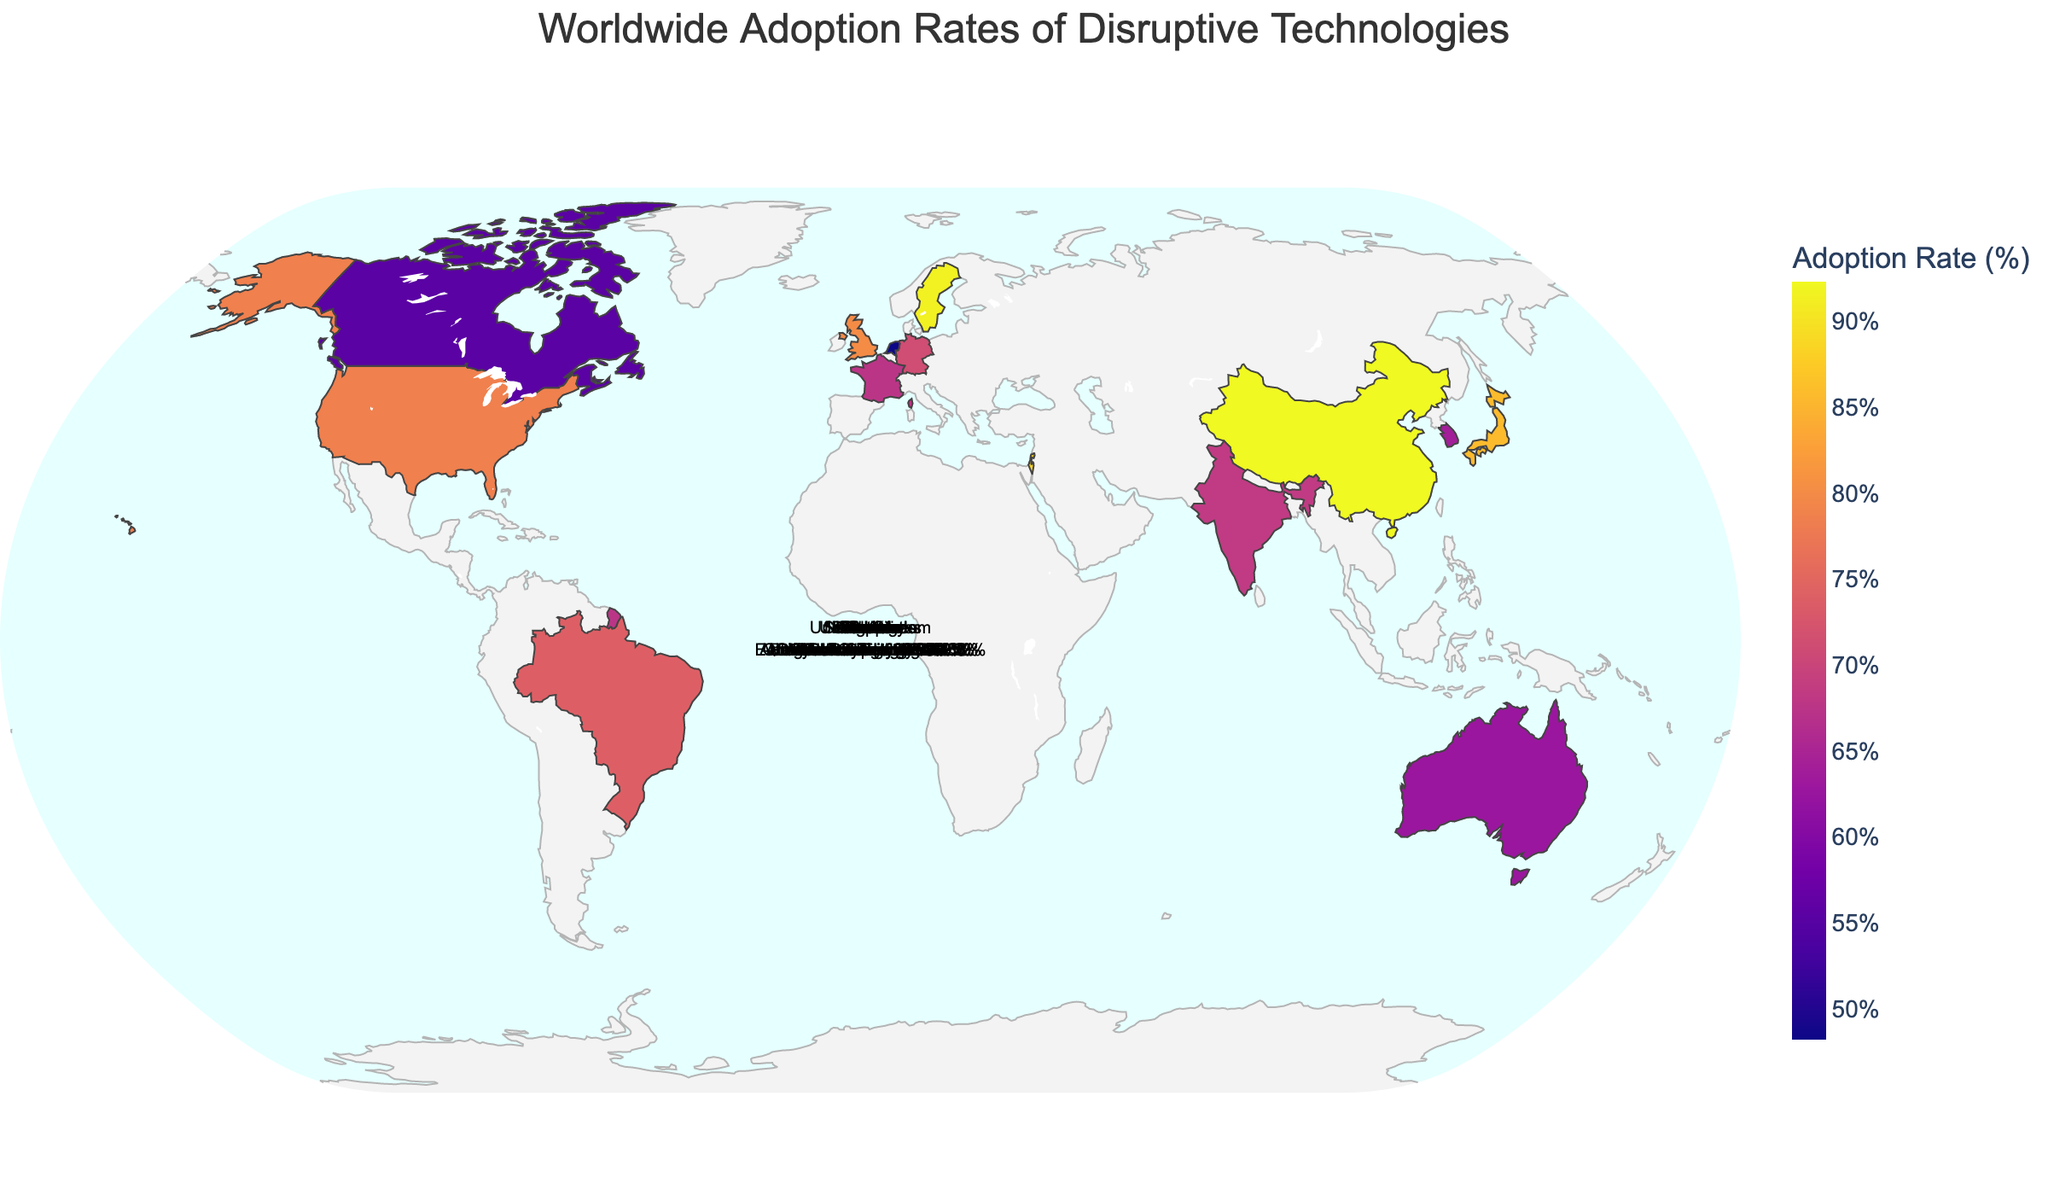What is the title of the figure? The title of the figure is usually displayed at the top, central part of the map for clarity.
Answer: Worldwide Adoption Rates of Disruptive Technologies Which country has the highest adoption rate of 5G Networks? To find this, look for the country associated with 5G Networks and check its adoption rate.
Answer: China What is the adoption rate of Cybersecurity technology in Israel? Locate Israel on the map and check the corresponding adoption rate displayed for Cybersecurity.
Answer: 88.6% Compare the adoption rates of Artificial Intelligence in the United States and Digital Payments in India. Which is higher? First, find the adoption rate of Artificial Intelligence in the United States (78.5%) and Digital Payments in India (68.4%). Then, compare the two values.
Answer: United States Calculate the average adoption rate of the technologies listed. Add all the adoption rates together and then divide by the number of countries to find the average. (78.5 + 92.3 + 85.7 + 71.2 + 63.9 + 80.1 + 68.4 + 88.6 + 59.8 + 91.5 + 55.3 + 62.7 + 73.9 + 67.5 + 48.2) / 15 ≈ 73.15
Answer: 73.15% What is the median adoption rate of the technologies listed across all countries? Arrange all the adoption rates in ascending order and find the middle value. If there is an odd number of rates, the median is the middle one. If even, it is the average of the two in the middle. (48.2, 55.3, 59.8, 62.7, 63.9, 67.5, 68.4, 71.2, 73.9, 78.5, 80.1, 85.7, 88.6, 91.5, 92.3) → Median = 71.2
Answer: 71.2% Identify the country with the lowest adoption rate and specify the technology and adoption rate. Find the minimum adoption rate on the map and identify the associated country and technology.
Answer: Netherlands, Quantum Computing, 48.2% How do the adoption rates of Cloud Computing in the United Kingdom and Virtual Reality in Canada compare? Find the adoption rates for Cloud Computing (80.1%) and Virtual Reality (55.3%) and compare them.
Answer: Cloud Computing is higher Which country in Asia has the highest adoption rate of a disruptive technology and what is the technology? Identify the countries in Asia (China, Japan, South Korea, India, Israel, Singapore) and compare their adoption rates to find the highest.
Answer: China, 5G Networks Summarize the adoption rates in terms of regions (e.g., North America, Europe, Asia). Which region has the highest average adoption rate? Group the countries by their respective regions and calculate the average adoption rate for each region. North America (United States, Canada): (78.5 + 55.3) / 2 = 66.9, Europe (Germany, United Kingdom, France, Netherlands, Sweden): (71.2 + 80.1 + 67.5 + 48.2 + 91.5) / 5 = 71.7, Asia (China, Japan, South Korea, India, Israel, Singapore): (92.3 + 85.7 + 63.9 + 68.4 + 88.6 + 59.8) / 6 = 76.45
Answer: Asia 